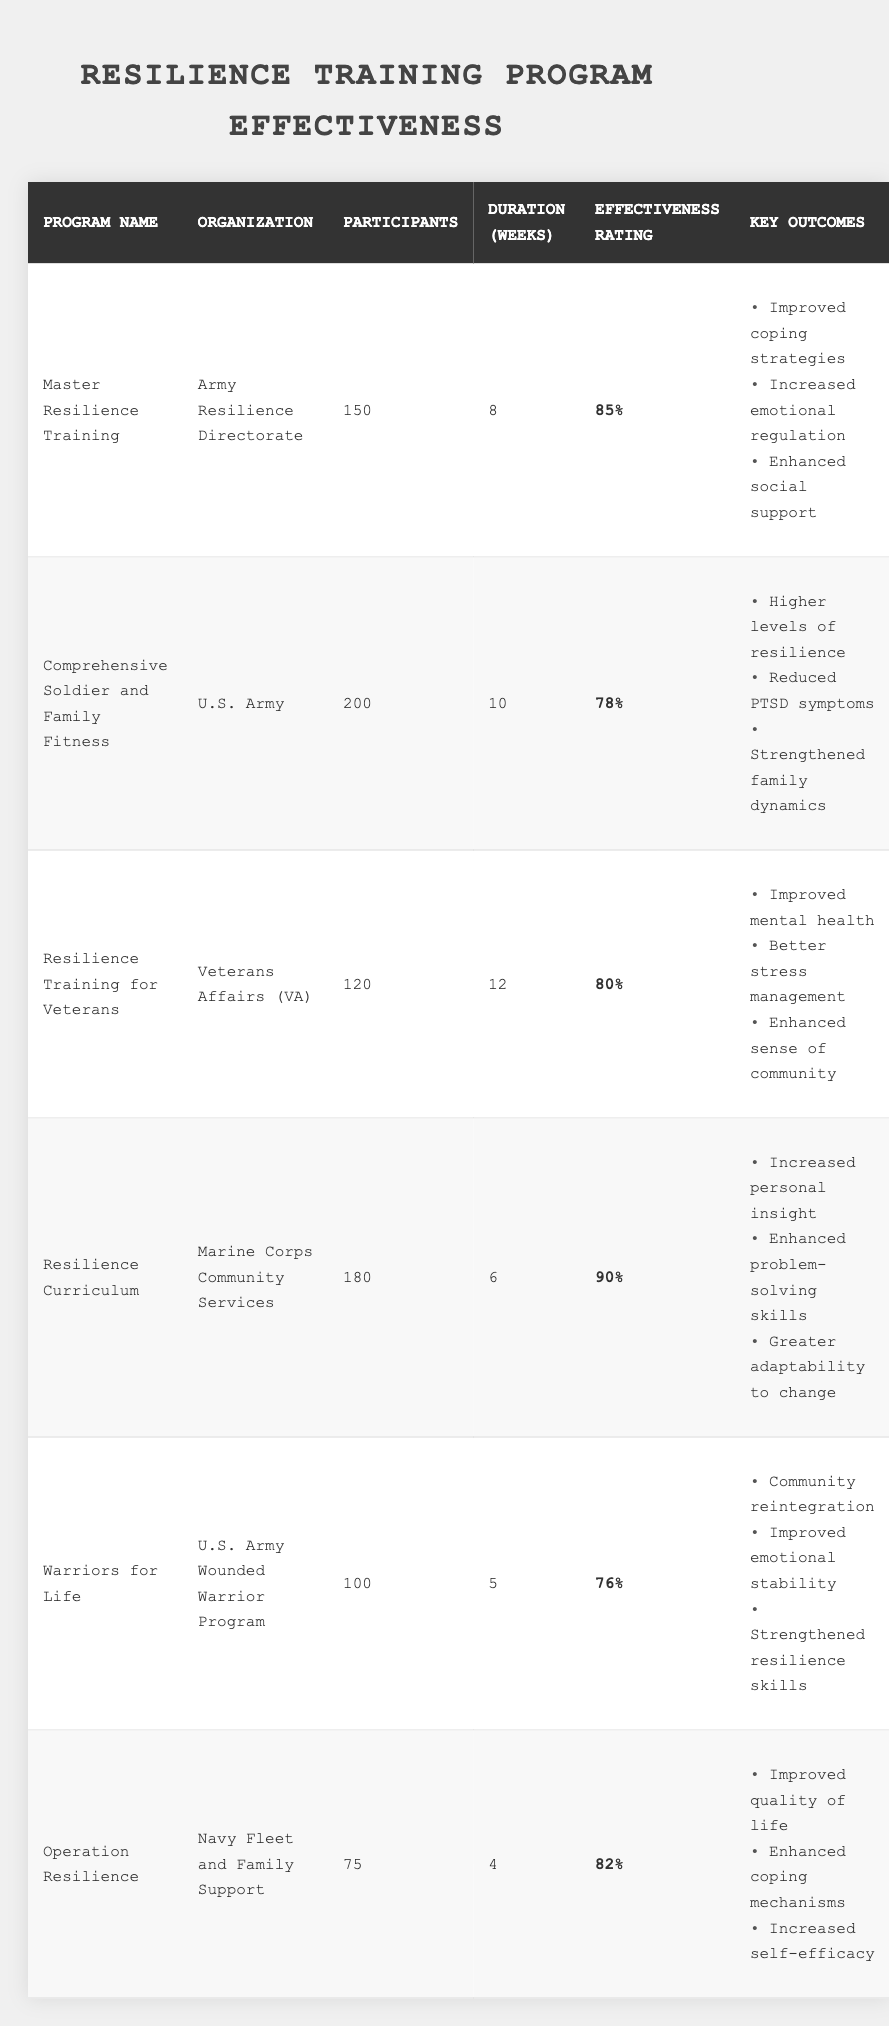What is the effectiveness rating of the "Master Resilience Training" program? The effectiveness rating is listed in the table under the "Effectiveness Rating" column for the "Master Resilience Training" program, which shows a value of 85%.
Answer: 85% How many participants were involved in the "Comprehensive Soldier and Family Fitness" program? The number of participants is found in the "Participants" column of the "Comprehensive Soldier and Family Fitness" program row, showing it as 200.
Answer: 200 Which program had the highest effectiveness rating? By comparing the effectiveness ratings in the table, the "Resilience Curriculum" program has the highest rating at 90%.
Answer: Resilience Curriculum What is the total number of participants across all programs? To find the total number of participants, sum the individual participant counts from each program: 150 + 200 + 120 + 180 + 100 + 75 = 925.
Answer: 925 How many weeks did the "Warriors for Life" program last? The duration in weeks is directly listed in the "Duration (Weeks)" column for the "Warriors for Life" program, which indicates it lasted for 5 weeks.
Answer: 5 Does the "Operation Resilience" program have an effectiveness rating above 80%? The effectiveness rating for "Operation Resilience" is 82%, which is indeed above 80%. This makes the statement true.
Answer: Yes What is the average duration of all resilience training programs? Calculate the average by summing all the durations: (8 + 10 + 12 + 6 + 5 + 4) = 45 weeks. Divide by the number of programs, 6: 45 / 6 = 7.5 weeks.
Answer: 7.5 weeks Which organization offers the "Resilience Training for Veterans" program? The organization responsible for the "Resilience Training for Veterans" program is stated in the "Organization" column of its row, which is the Veterans Affairs (VA).
Answer: Veterans Affairs (VA) Is there a program with an effectiveness rating lower than 75%? By reviewing the effectiveness ratings in the table, the lowest rating is 76% for "Warriors for Life," suggesting there is no program rated below 75%.
Answer: No What two key outcomes are shared by the "Master Resilience Training" and "Resilience Training for Veterans" programs? By checking the "Key Outcomes" listed for each program, both share improved coping strategies and stress management as key outcomes.
Answer: Improved coping strategies, Better stress management 